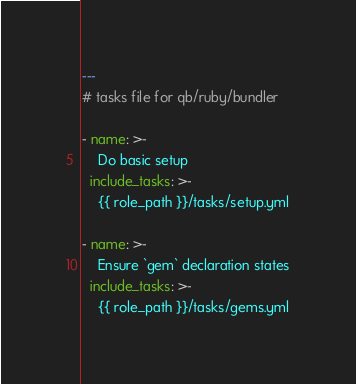<code> <loc_0><loc_0><loc_500><loc_500><_YAML_>---
# tasks file for qb/ruby/bundler

- name: >-
    Do basic setup
  include_tasks: >-
    {{ role_path }}/tasks/setup.yml

- name: >-
    Ensure `gem` declaration states
  include_tasks: >-
    {{ role_path }}/tasks/gems.yml
</code> 